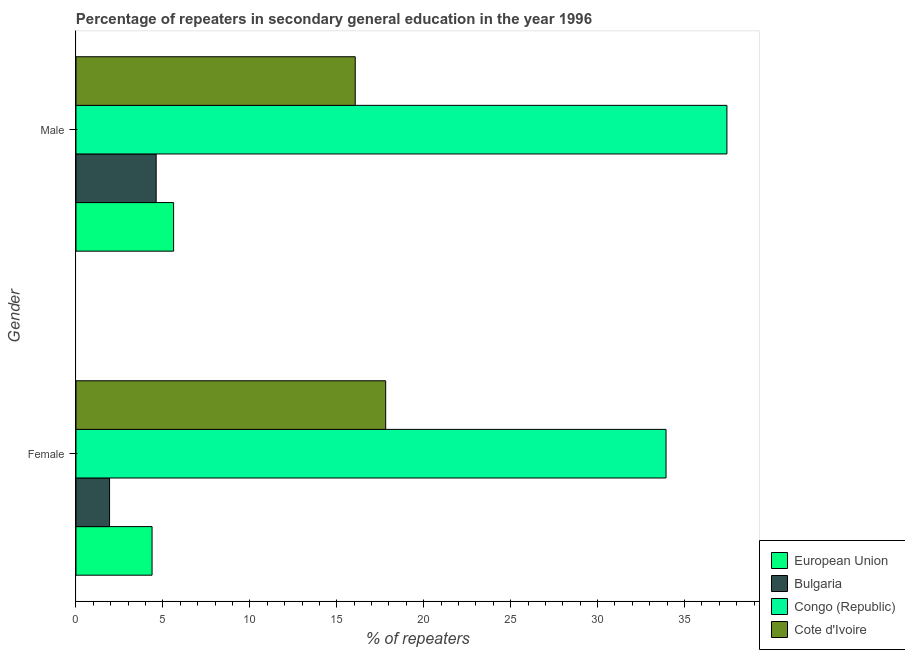Are the number of bars per tick equal to the number of legend labels?
Provide a succinct answer. Yes. Are the number of bars on each tick of the Y-axis equal?
Make the answer very short. Yes. How many bars are there on the 1st tick from the top?
Your answer should be compact. 4. How many bars are there on the 1st tick from the bottom?
Your answer should be compact. 4. What is the percentage of male repeaters in Cote d'Ivoire?
Make the answer very short. 16.06. Across all countries, what is the maximum percentage of male repeaters?
Your answer should be compact. 37.44. Across all countries, what is the minimum percentage of male repeaters?
Ensure brevity in your answer.  4.61. In which country was the percentage of male repeaters maximum?
Ensure brevity in your answer.  Congo (Republic). What is the total percentage of female repeaters in the graph?
Ensure brevity in your answer.  58.06. What is the difference between the percentage of male repeaters in European Union and that in Cote d'Ivoire?
Provide a succinct answer. -10.45. What is the difference between the percentage of male repeaters in Cote d'Ivoire and the percentage of female repeaters in Bulgaria?
Your response must be concise. 14.13. What is the average percentage of male repeaters per country?
Provide a succinct answer. 15.93. What is the difference between the percentage of male repeaters and percentage of female repeaters in European Union?
Make the answer very short. 1.24. What is the ratio of the percentage of female repeaters in Bulgaria to that in Cote d'Ivoire?
Provide a succinct answer. 0.11. Is the percentage of female repeaters in Congo (Republic) less than that in Cote d'Ivoire?
Provide a short and direct response. No. In how many countries, is the percentage of male repeaters greater than the average percentage of male repeaters taken over all countries?
Your response must be concise. 2. What does the 2nd bar from the top in Female represents?
Provide a succinct answer. Congo (Republic). How many bars are there?
Your answer should be compact. 8. Are all the bars in the graph horizontal?
Make the answer very short. Yes. What is the difference between two consecutive major ticks on the X-axis?
Keep it short and to the point. 5. How many legend labels are there?
Offer a very short reply. 4. How are the legend labels stacked?
Keep it short and to the point. Vertical. What is the title of the graph?
Offer a very short reply. Percentage of repeaters in secondary general education in the year 1996. Does "Italy" appear as one of the legend labels in the graph?
Provide a succinct answer. No. What is the label or title of the X-axis?
Provide a succinct answer. % of repeaters. What is the label or title of the Y-axis?
Give a very brief answer. Gender. What is the % of repeaters in European Union in Female?
Keep it short and to the point. 4.38. What is the % of repeaters of Bulgaria in Female?
Make the answer very short. 1.93. What is the % of repeaters of Congo (Republic) in Female?
Keep it short and to the point. 33.94. What is the % of repeaters of Cote d'Ivoire in Female?
Give a very brief answer. 17.81. What is the % of repeaters of European Union in Male?
Your answer should be very brief. 5.61. What is the % of repeaters of Bulgaria in Male?
Offer a terse response. 4.61. What is the % of repeaters in Congo (Republic) in Male?
Your answer should be very brief. 37.44. What is the % of repeaters in Cote d'Ivoire in Male?
Offer a terse response. 16.06. Across all Gender, what is the maximum % of repeaters in European Union?
Your answer should be compact. 5.61. Across all Gender, what is the maximum % of repeaters in Bulgaria?
Provide a succinct answer. 4.61. Across all Gender, what is the maximum % of repeaters in Congo (Republic)?
Provide a short and direct response. 37.44. Across all Gender, what is the maximum % of repeaters in Cote d'Ivoire?
Your answer should be very brief. 17.81. Across all Gender, what is the minimum % of repeaters of European Union?
Provide a short and direct response. 4.38. Across all Gender, what is the minimum % of repeaters of Bulgaria?
Give a very brief answer. 1.93. Across all Gender, what is the minimum % of repeaters of Congo (Republic)?
Your answer should be compact. 33.94. Across all Gender, what is the minimum % of repeaters in Cote d'Ivoire?
Give a very brief answer. 16.06. What is the total % of repeaters of European Union in the graph?
Make the answer very short. 9.99. What is the total % of repeaters in Bulgaria in the graph?
Keep it short and to the point. 6.54. What is the total % of repeaters in Congo (Republic) in the graph?
Give a very brief answer. 71.38. What is the total % of repeaters in Cote d'Ivoire in the graph?
Your answer should be compact. 33.88. What is the difference between the % of repeaters of European Union in Female and that in Male?
Offer a terse response. -1.24. What is the difference between the % of repeaters of Bulgaria in Female and that in Male?
Offer a very short reply. -2.68. What is the difference between the % of repeaters of Congo (Republic) in Female and that in Male?
Make the answer very short. -3.5. What is the difference between the % of repeaters of Cote d'Ivoire in Female and that in Male?
Your answer should be compact. 1.75. What is the difference between the % of repeaters in European Union in Female and the % of repeaters in Bulgaria in Male?
Your response must be concise. -0.24. What is the difference between the % of repeaters in European Union in Female and the % of repeaters in Congo (Republic) in Male?
Offer a very short reply. -33.07. What is the difference between the % of repeaters of European Union in Female and the % of repeaters of Cote d'Ivoire in Male?
Keep it short and to the point. -11.69. What is the difference between the % of repeaters in Bulgaria in Female and the % of repeaters in Congo (Republic) in Male?
Provide a short and direct response. -35.51. What is the difference between the % of repeaters of Bulgaria in Female and the % of repeaters of Cote d'Ivoire in Male?
Your answer should be compact. -14.13. What is the difference between the % of repeaters in Congo (Republic) in Female and the % of repeaters in Cote d'Ivoire in Male?
Ensure brevity in your answer.  17.88. What is the average % of repeaters of European Union per Gender?
Provide a short and direct response. 5. What is the average % of repeaters of Bulgaria per Gender?
Ensure brevity in your answer.  3.27. What is the average % of repeaters of Congo (Republic) per Gender?
Your answer should be very brief. 35.69. What is the average % of repeaters of Cote d'Ivoire per Gender?
Offer a terse response. 16.94. What is the difference between the % of repeaters in European Union and % of repeaters in Bulgaria in Female?
Your response must be concise. 2.44. What is the difference between the % of repeaters in European Union and % of repeaters in Congo (Republic) in Female?
Your answer should be very brief. -29.57. What is the difference between the % of repeaters in European Union and % of repeaters in Cote d'Ivoire in Female?
Make the answer very short. -13.44. What is the difference between the % of repeaters in Bulgaria and % of repeaters in Congo (Republic) in Female?
Provide a succinct answer. -32.01. What is the difference between the % of repeaters in Bulgaria and % of repeaters in Cote d'Ivoire in Female?
Ensure brevity in your answer.  -15.88. What is the difference between the % of repeaters in Congo (Republic) and % of repeaters in Cote d'Ivoire in Female?
Offer a very short reply. 16.13. What is the difference between the % of repeaters in European Union and % of repeaters in Bulgaria in Male?
Give a very brief answer. 1. What is the difference between the % of repeaters of European Union and % of repeaters of Congo (Republic) in Male?
Keep it short and to the point. -31.83. What is the difference between the % of repeaters of European Union and % of repeaters of Cote d'Ivoire in Male?
Provide a short and direct response. -10.45. What is the difference between the % of repeaters in Bulgaria and % of repeaters in Congo (Republic) in Male?
Give a very brief answer. -32.83. What is the difference between the % of repeaters in Bulgaria and % of repeaters in Cote d'Ivoire in Male?
Your answer should be compact. -11.45. What is the difference between the % of repeaters of Congo (Republic) and % of repeaters of Cote d'Ivoire in Male?
Provide a succinct answer. 21.38. What is the ratio of the % of repeaters in European Union in Female to that in Male?
Keep it short and to the point. 0.78. What is the ratio of the % of repeaters of Bulgaria in Female to that in Male?
Offer a very short reply. 0.42. What is the ratio of the % of repeaters in Congo (Republic) in Female to that in Male?
Provide a short and direct response. 0.91. What is the ratio of the % of repeaters in Cote d'Ivoire in Female to that in Male?
Give a very brief answer. 1.11. What is the difference between the highest and the second highest % of repeaters in European Union?
Provide a succinct answer. 1.24. What is the difference between the highest and the second highest % of repeaters of Bulgaria?
Your answer should be compact. 2.68. What is the difference between the highest and the second highest % of repeaters of Congo (Republic)?
Keep it short and to the point. 3.5. What is the difference between the highest and the second highest % of repeaters in Cote d'Ivoire?
Give a very brief answer. 1.75. What is the difference between the highest and the lowest % of repeaters in European Union?
Ensure brevity in your answer.  1.24. What is the difference between the highest and the lowest % of repeaters of Bulgaria?
Provide a succinct answer. 2.68. What is the difference between the highest and the lowest % of repeaters in Congo (Republic)?
Your answer should be compact. 3.5. What is the difference between the highest and the lowest % of repeaters in Cote d'Ivoire?
Ensure brevity in your answer.  1.75. 